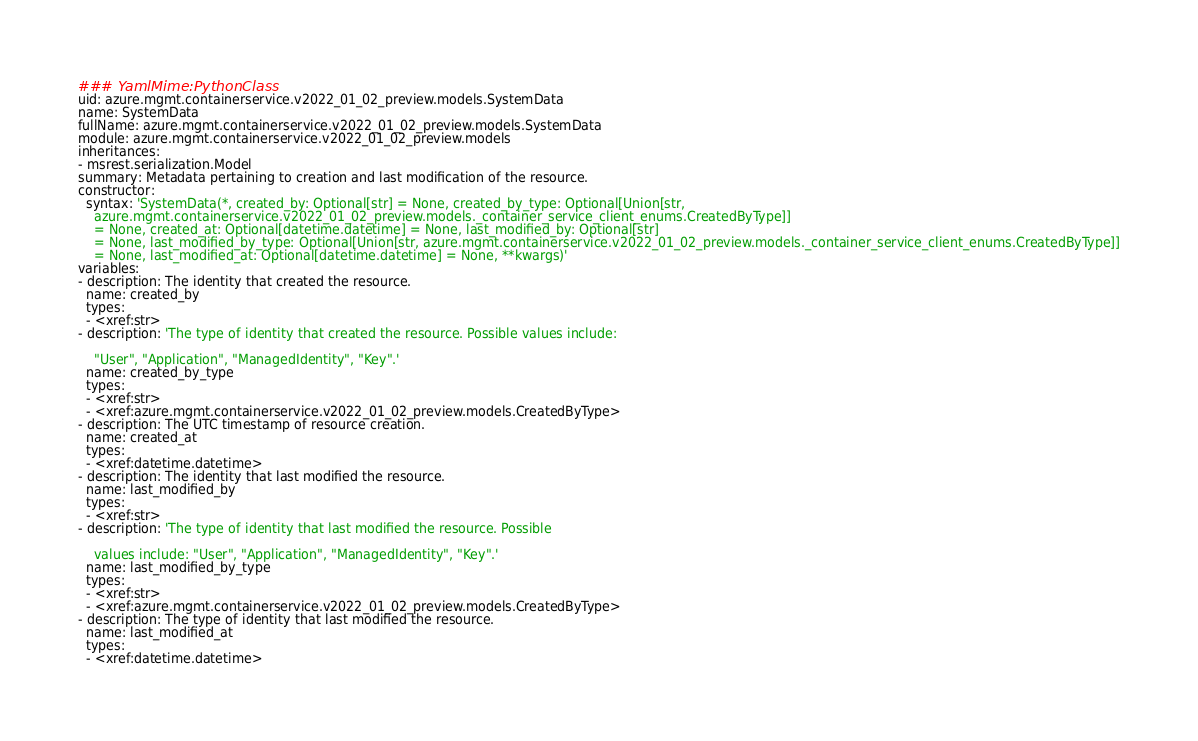Convert code to text. <code><loc_0><loc_0><loc_500><loc_500><_YAML_>### YamlMime:PythonClass
uid: azure.mgmt.containerservice.v2022_01_02_preview.models.SystemData
name: SystemData
fullName: azure.mgmt.containerservice.v2022_01_02_preview.models.SystemData
module: azure.mgmt.containerservice.v2022_01_02_preview.models
inheritances:
- msrest.serialization.Model
summary: Metadata pertaining to creation and last modification of the resource.
constructor:
  syntax: 'SystemData(*, created_by: Optional[str] = None, created_by_type: Optional[Union[str,
    azure.mgmt.containerservice.v2022_01_02_preview.models._container_service_client_enums.CreatedByType]]
    = None, created_at: Optional[datetime.datetime] = None, last_modified_by: Optional[str]
    = None, last_modified_by_type: Optional[Union[str, azure.mgmt.containerservice.v2022_01_02_preview.models._container_service_client_enums.CreatedByType]]
    = None, last_modified_at: Optional[datetime.datetime] = None, **kwargs)'
variables:
- description: The identity that created the resource.
  name: created_by
  types:
  - <xref:str>
- description: 'The type of identity that created the resource. Possible values include:

    "User", "Application", "ManagedIdentity", "Key".'
  name: created_by_type
  types:
  - <xref:str>
  - <xref:azure.mgmt.containerservice.v2022_01_02_preview.models.CreatedByType>
- description: The UTC timestamp of resource creation.
  name: created_at
  types:
  - <xref:datetime.datetime>
- description: The identity that last modified the resource.
  name: last_modified_by
  types:
  - <xref:str>
- description: 'The type of identity that last modified the resource. Possible

    values include: "User", "Application", "ManagedIdentity", "Key".'
  name: last_modified_by_type
  types:
  - <xref:str>
  - <xref:azure.mgmt.containerservice.v2022_01_02_preview.models.CreatedByType>
- description: The type of identity that last modified the resource.
  name: last_modified_at
  types:
  - <xref:datetime.datetime>
</code> 